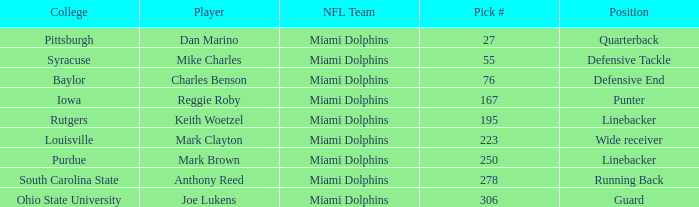Which Position has a Pick # lower than 278 for Player Charles Benson? Defensive End. 